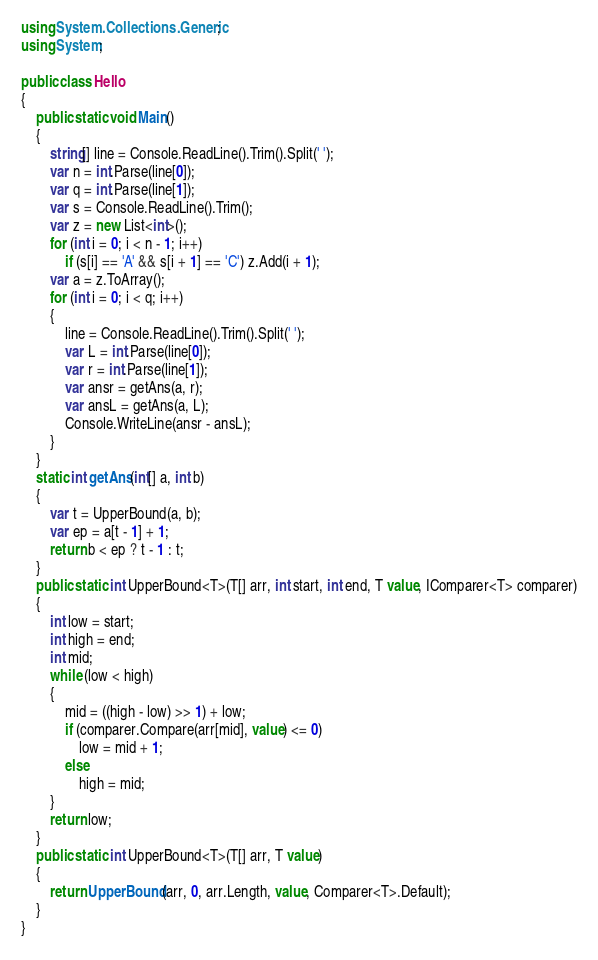<code> <loc_0><loc_0><loc_500><loc_500><_C#_>using System.Collections.Generic;
using System;

public class Hello
{
    public static void Main()
    {
        string[] line = Console.ReadLine().Trim().Split(' ');
        var n = int.Parse(line[0]);
        var q = int.Parse(line[1]);
        var s = Console.ReadLine().Trim();
        var z = new List<int>();
        for (int i = 0; i < n - 1; i++)
            if (s[i] == 'A' && s[i + 1] == 'C') z.Add(i + 1);
        var a = z.ToArray();
        for (int i = 0; i < q; i++)
        {
            line = Console.ReadLine().Trim().Split(' ');
            var L = int.Parse(line[0]);
            var r = int.Parse(line[1]);
            var ansr = getAns(a, r);
            var ansL = getAns(a, L);
            Console.WriteLine(ansr - ansL);
        }
    }
    static int getAns(int[] a, int b)
    {
        var t = UpperBound(a, b);
        var ep = a[t - 1] + 1;
        return b < ep ? t - 1 : t;
    }
    public static int UpperBound<T>(T[] arr, int start, int end, T value, IComparer<T> comparer)
    {
        int low = start;
        int high = end;
        int mid;
        while (low < high)
        {
            mid = ((high - low) >> 1) + low;
            if (comparer.Compare(arr[mid], value) <= 0)
                low = mid + 1;
            else
                high = mid;
        }
        return low;
    }
    public static int UpperBound<T>(T[] arr, T value)
    {
        return UpperBound(arr, 0, arr.Length, value, Comparer<T>.Default);
    }
}</code> 